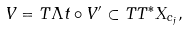<formula> <loc_0><loc_0><loc_500><loc_500>V = T \Lambda t \circ V ^ { \prime } \subset T T ^ { * } X _ { c _ { j } } ,</formula> 